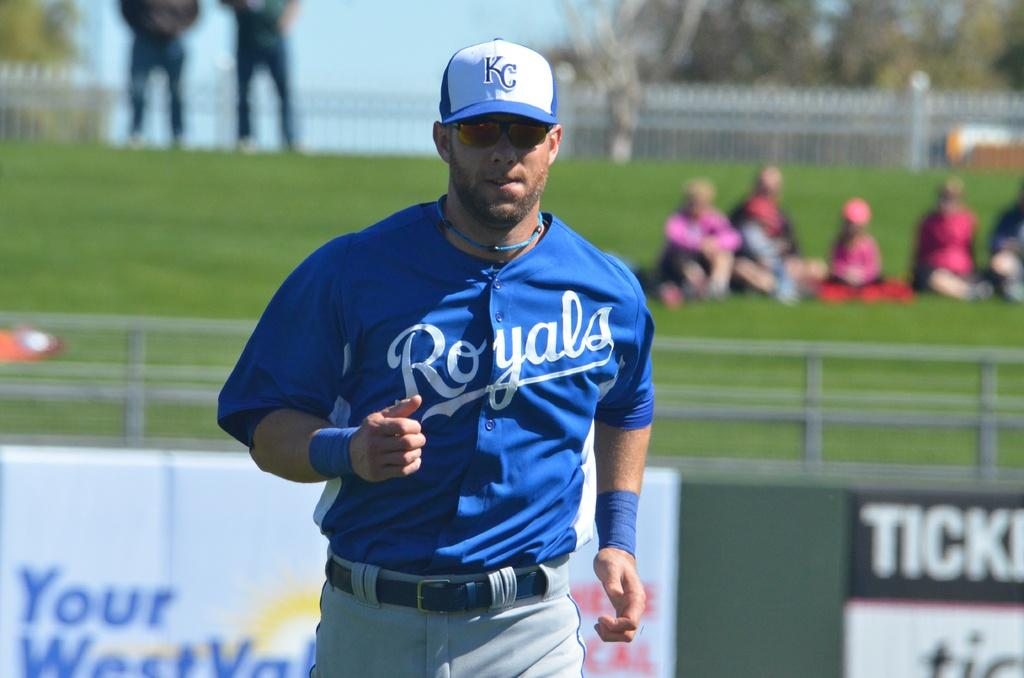Who is present in the image? There is a man in the image. What is the man wearing on his head? The man is wearing a cap. What type of eyewear is the man wearing? The man is wearing spectacles. What color is the shirt the man is wearing? The man is wearing a blue shirt. What type of accessory is the man wearing on his wrists? The man is wearing blue bands. What color are the pants the man is wearing? The man is wearing gray pants. Where is the man standing in the image? The man is standing in a ground. How would you describe the background of the image? The background of the image is blurred. What type of square advice does the man give in the image? There is no square or advice present in the image; it only features a man standing in a ground. 